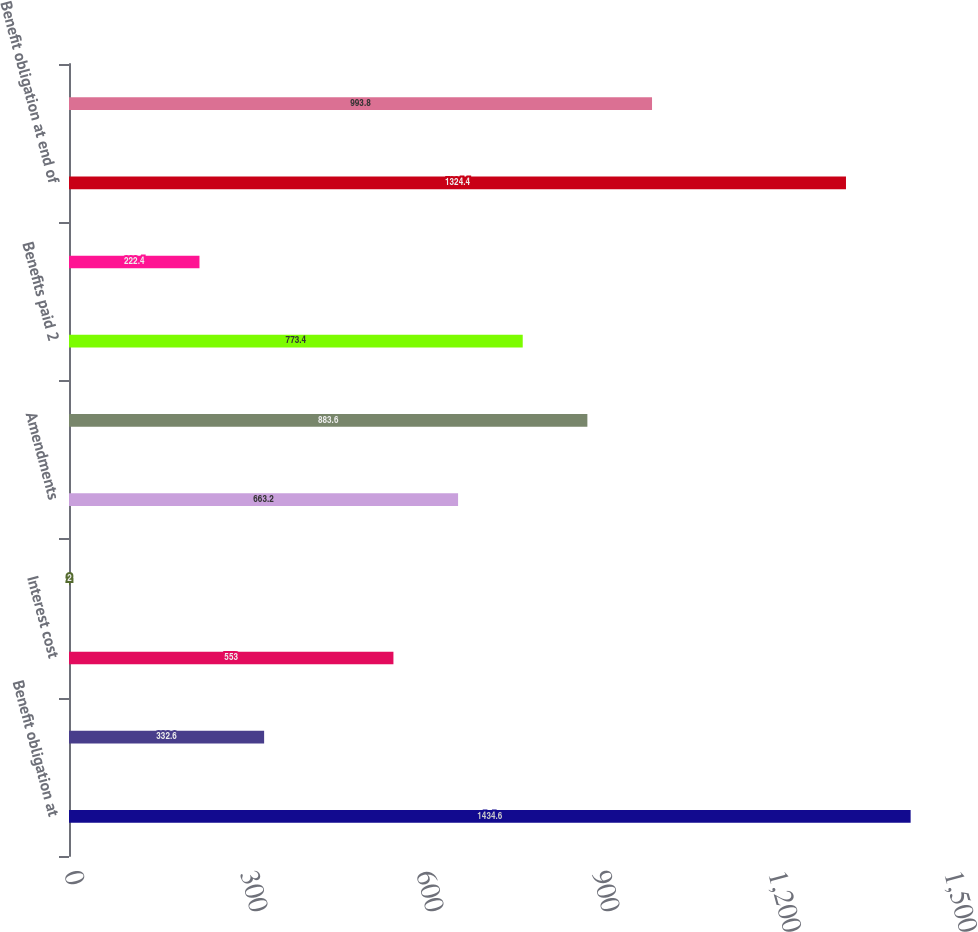Convert chart to OTSL. <chart><loc_0><loc_0><loc_500><loc_500><bar_chart><fcel>Benefit obligation at<fcel>Service cost<fcel>Interest cost<fcel>Foreign currency exchange rate<fcel>Amendments<fcel>Actuarial loss (gain)<fcel>Benefits paid 2<fcel>Other 3<fcel>Benefit obligation at end of<fcel>Fair value of plan assets at<nl><fcel>1434.6<fcel>332.6<fcel>553<fcel>2<fcel>663.2<fcel>883.6<fcel>773.4<fcel>222.4<fcel>1324.4<fcel>993.8<nl></chart> 